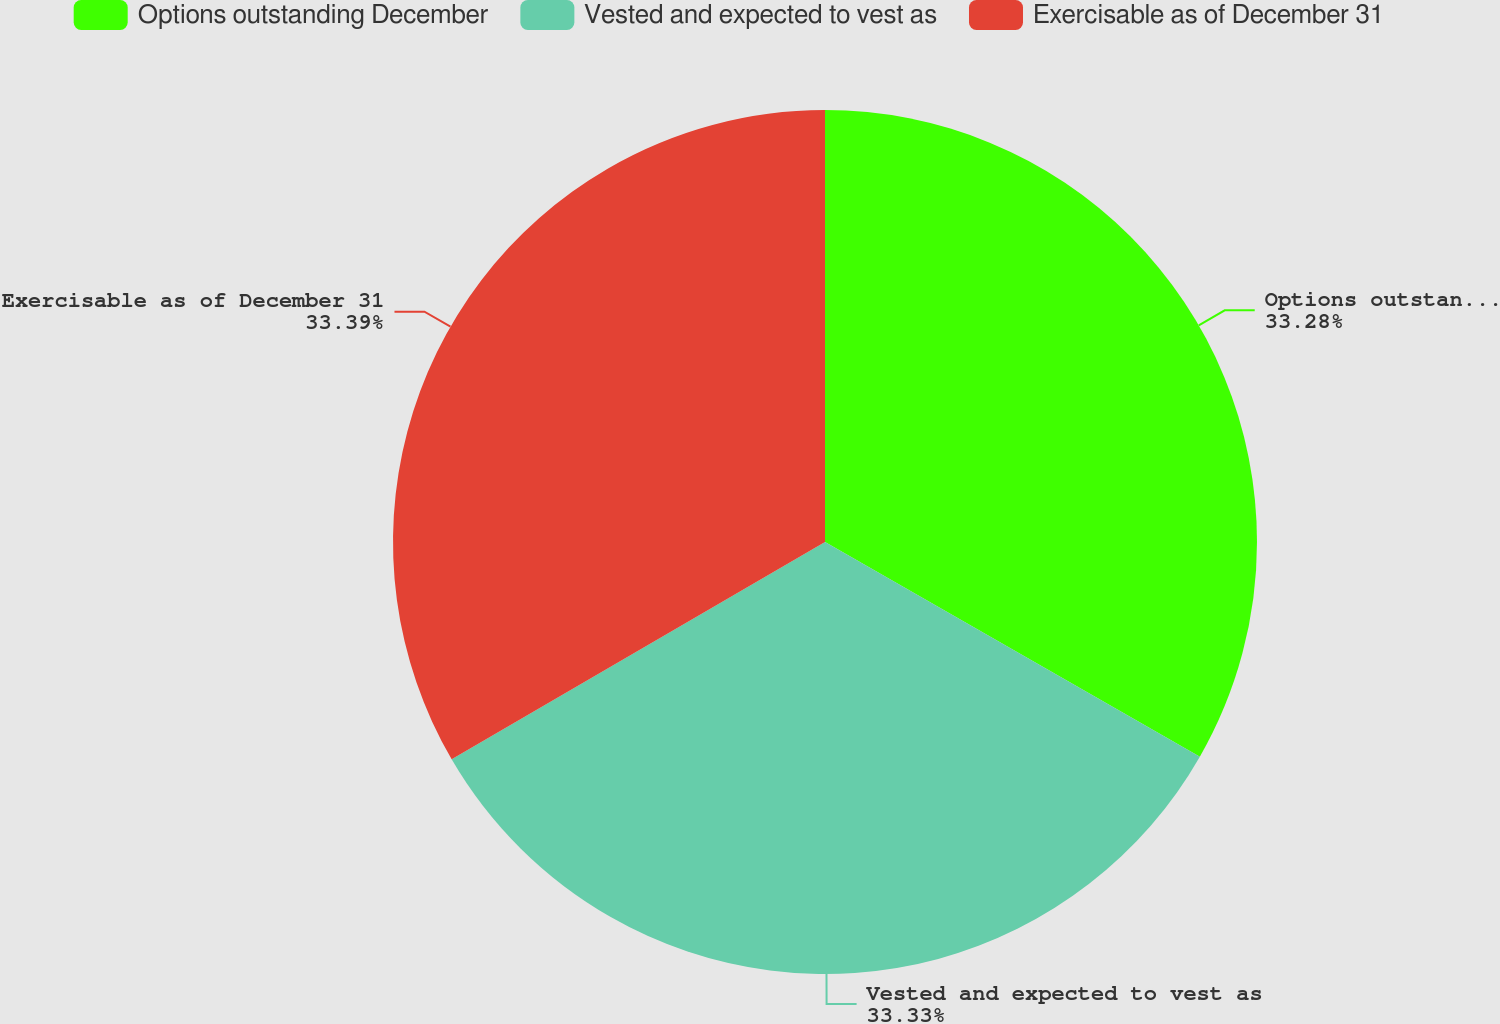<chart> <loc_0><loc_0><loc_500><loc_500><pie_chart><fcel>Options outstanding December<fcel>Vested and expected to vest as<fcel>Exercisable as of December 31<nl><fcel>33.28%<fcel>33.33%<fcel>33.39%<nl></chart> 